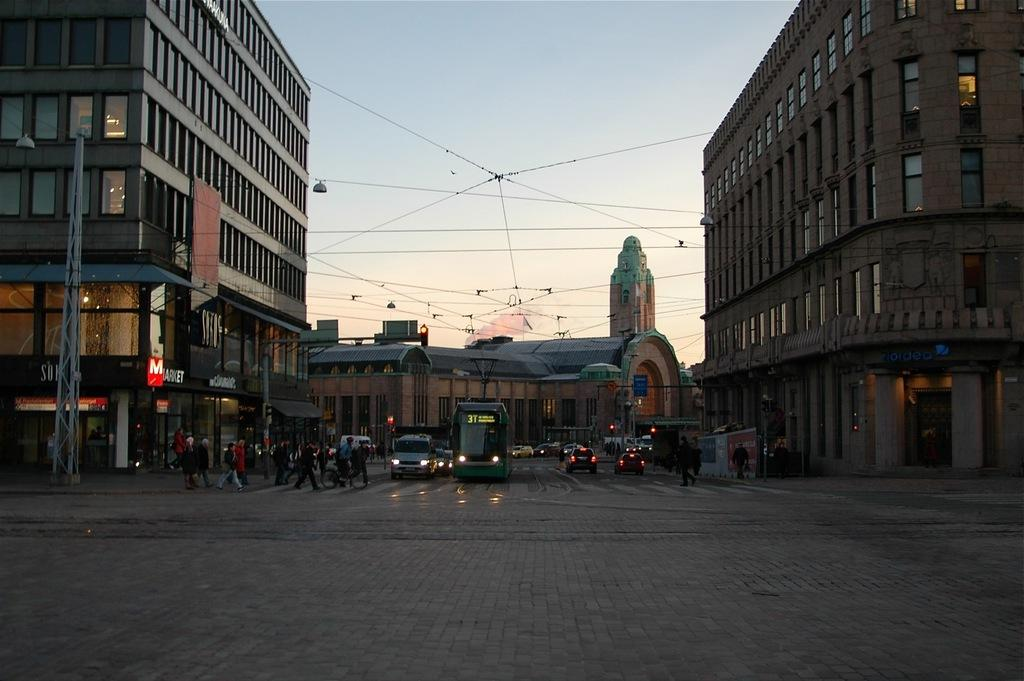What can be seen on the road in the image? There are vehicles on the road in the image. What else is present in the image besides vehicles? There is a group of people standing in the image, as well as buildings, cables, and boards. Can you describe the background of the image? The sky is visible in the background of the image. What type of quill is being used by the children in the image? There are no children or quills present in the image. What reward is being given to the people in the image? There is no reward being given in the image; it only shows vehicles, a group of people, buildings, cables, boards, and the sky. 